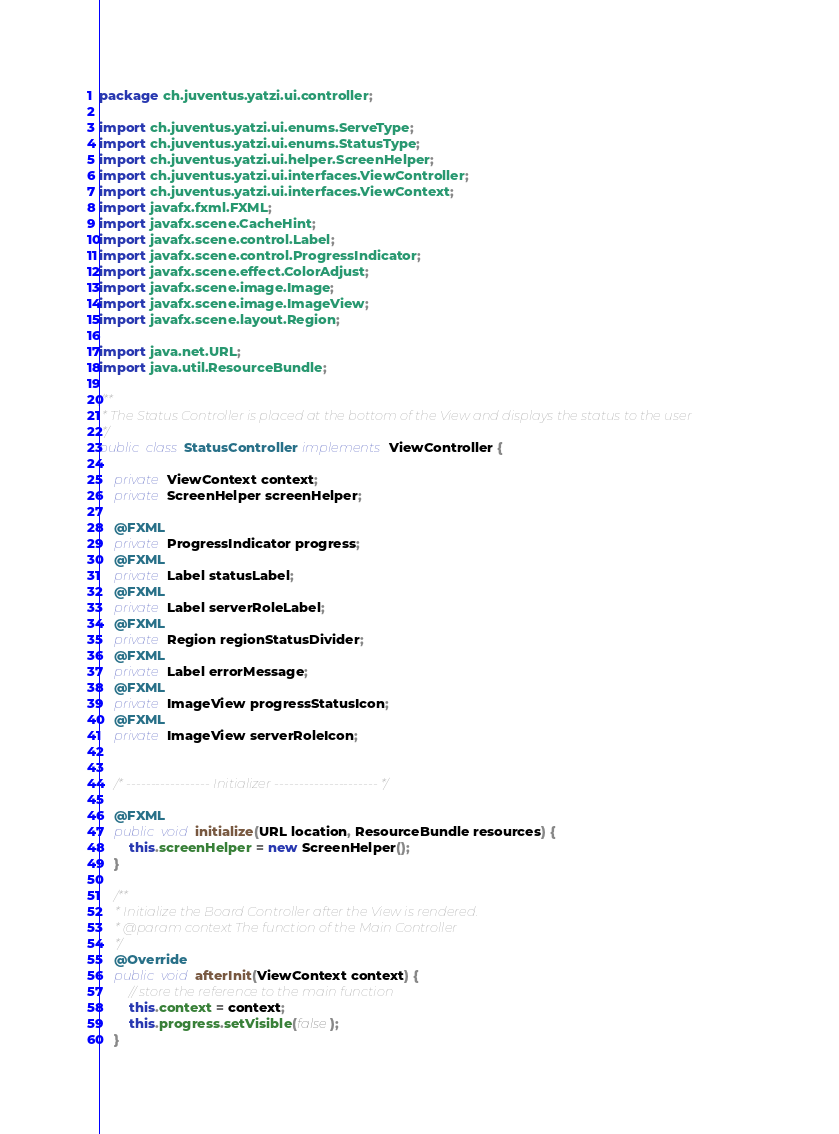<code> <loc_0><loc_0><loc_500><loc_500><_Java_>package ch.juventus.yatzi.ui.controller;

import ch.juventus.yatzi.ui.enums.ServeType;
import ch.juventus.yatzi.ui.enums.StatusType;
import ch.juventus.yatzi.ui.helper.ScreenHelper;
import ch.juventus.yatzi.ui.interfaces.ViewController;
import ch.juventus.yatzi.ui.interfaces.ViewContext;
import javafx.fxml.FXML;
import javafx.scene.CacheHint;
import javafx.scene.control.Label;
import javafx.scene.control.ProgressIndicator;
import javafx.scene.effect.ColorAdjust;
import javafx.scene.image.Image;
import javafx.scene.image.ImageView;
import javafx.scene.layout.Region;

import java.net.URL;
import java.util.ResourceBundle;

/**
 * The Status Controller is placed at the bottom of the View and displays the status to the user
 */
public class StatusController implements ViewController {

    private ViewContext context;
    private ScreenHelper screenHelper;

    @FXML
    private ProgressIndicator progress;
    @FXML
    private Label statusLabel;
    @FXML
    private Label serverRoleLabel;
    @FXML
    private Region regionStatusDivider;
    @FXML
    private Label errorMessage;
    @FXML
    private ImageView progressStatusIcon;
    @FXML
    private ImageView serverRoleIcon;


    /* ----------------- Initializer --------------------- */

    @FXML
    public void initialize(URL location, ResourceBundle resources) {
        this.screenHelper = new ScreenHelper();
    }

    /**
     * Initialize the Board Controller after the View is rendered.
     * @param context The function of the Main Controller
     */
    @Override
    public void afterInit(ViewContext context) {
        // store the reference to the main function
        this.context = context;
        this.progress.setVisible(false);
    }
</code> 